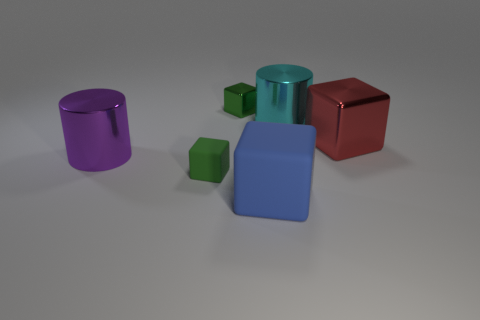Subtract all yellow cylinders. How many green blocks are left? 2 Subtract 1 cubes. How many cubes are left? 3 Subtract all blue cubes. How many cubes are left? 3 Subtract all large red metallic blocks. How many blocks are left? 3 Add 1 tiny brown shiny objects. How many objects exist? 7 Subtract all cubes. How many objects are left? 2 Subtract all cyan blocks. Subtract all blue balls. How many blocks are left? 4 Add 2 cyan metallic things. How many cyan metallic things are left? 3 Add 3 cyan cylinders. How many cyan cylinders exist? 4 Subtract 0 green cylinders. How many objects are left? 6 